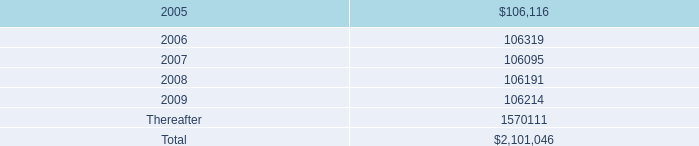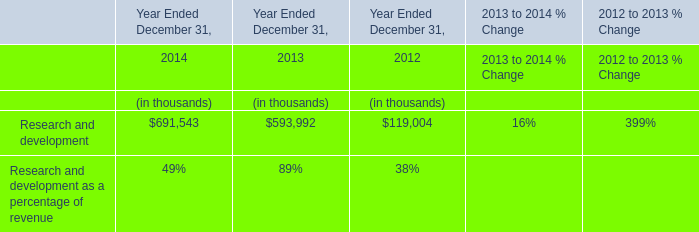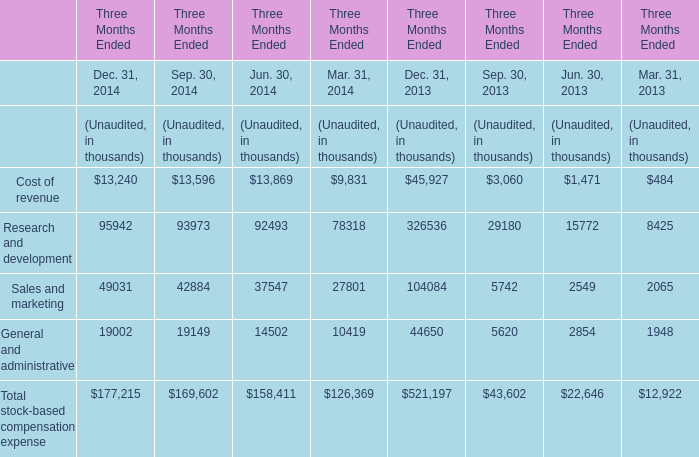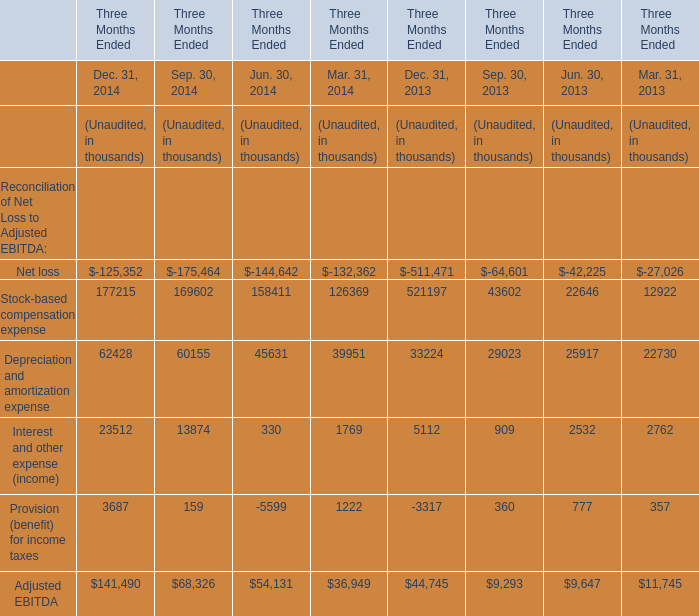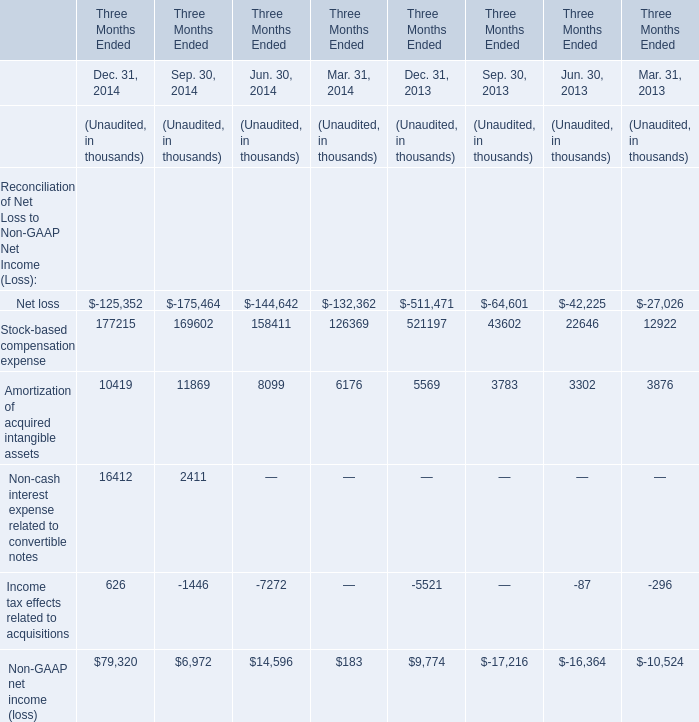what is the percentage change in aggregate rent expense from 2003 to 2004? 
Computations: ((118741000 - 113956000) / 113956000)
Answer: 0.04199. 